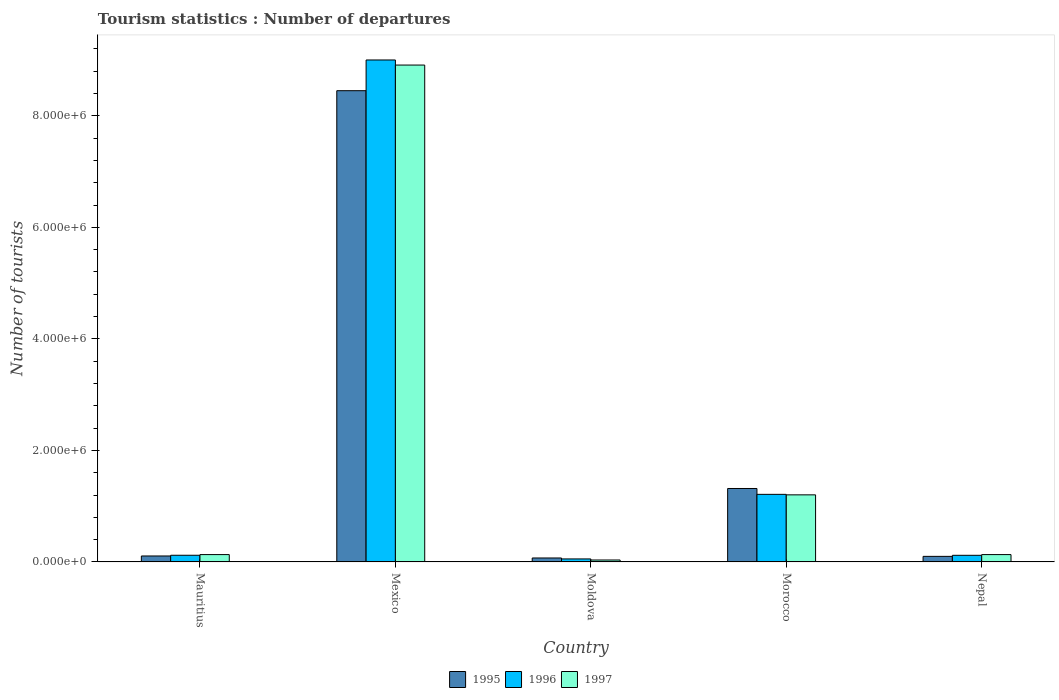How many different coloured bars are there?
Provide a succinct answer. 3. Are the number of bars per tick equal to the number of legend labels?
Offer a terse response. Yes. Are the number of bars on each tick of the X-axis equal?
Your answer should be very brief. Yes. How many bars are there on the 5th tick from the left?
Provide a short and direct response. 3. What is the label of the 1st group of bars from the left?
Your answer should be very brief. Mauritius. In how many cases, is the number of bars for a given country not equal to the number of legend labels?
Provide a short and direct response. 0. What is the number of tourist departures in 1995 in Morocco?
Your response must be concise. 1.32e+06. Across all countries, what is the maximum number of tourist departures in 1997?
Make the answer very short. 8.91e+06. Across all countries, what is the minimum number of tourist departures in 1995?
Your response must be concise. 7.10e+04. In which country was the number of tourist departures in 1995 maximum?
Offer a very short reply. Mexico. In which country was the number of tourist departures in 1996 minimum?
Provide a succinct answer. Moldova. What is the total number of tourist departures in 1997 in the graph?
Offer a terse response. 1.04e+07. What is the difference between the number of tourist departures in 1997 in Mexico and that in Nepal?
Provide a succinct answer. 8.78e+06. What is the difference between the number of tourist departures in 1997 in Moldova and the number of tourist departures in 1996 in Mauritius?
Your answer should be compact. -8.50e+04. What is the average number of tourist departures in 1996 per country?
Provide a succinct answer. 2.10e+06. What is the difference between the number of tourist departures of/in 1997 and number of tourist departures of/in 1996 in Morocco?
Offer a terse response. -9000. In how many countries, is the number of tourist departures in 1996 greater than 8400000?
Your answer should be compact. 1. What is the ratio of the number of tourist departures in 1997 in Mauritius to that in Morocco?
Provide a short and direct response. 0.11. Is the difference between the number of tourist departures in 1997 in Mexico and Nepal greater than the difference between the number of tourist departures in 1996 in Mexico and Nepal?
Ensure brevity in your answer.  No. What is the difference between the highest and the second highest number of tourist departures in 1995?
Make the answer very short. 8.34e+06. What is the difference between the highest and the lowest number of tourist departures in 1997?
Keep it short and to the point. 8.88e+06. Is the sum of the number of tourist departures in 1996 in Mexico and Nepal greater than the maximum number of tourist departures in 1997 across all countries?
Ensure brevity in your answer.  Yes. What does the 2nd bar from the left in Moldova represents?
Offer a very short reply. 1996. How many bars are there?
Offer a terse response. 15. How many countries are there in the graph?
Your response must be concise. 5. What is the difference between two consecutive major ticks on the Y-axis?
Your answer should be very brief. 2.00e+06. Are the values on the major ticks of Y-axis written in scientific E-notation?
Your answer should be compact. Yes. Does the graph contain any zero values?
Ensure brevity in your answer.  No. Where does the legend appear in the graph?
Provide a succinct answer. Bottom center. How many legend labels are there?
Your answer should be very brief. 3. What is the title of the graph?
Provide a short and direct response. Tourism statistics : Number of departures. Does "1971" appear as one of the legend labels in the graph?
Your answer should be compact. No. What is the label or title of the Y-axis?
Make the answer very short. Number of tourists. What is the Number of tourists of 1995 in Mauritius?
Keep it short and to the point. 1.07e+05. What is the Number of tourists of 1996 in Mauritius?
Provide a short and direct response. 1.20e+05. What is the Number of tourists of 1997 in Mauritius?
Give a very brief answer. 1.32e+05. What is the Number of tourists of 1995 in Mexico?
Your answer should be compact. 8.45e+06. What is the Number of tourists of 1996 in Mexico?
Your response must be concise. 9.00e+06. What is the Number of tourists of 1997 in Mexico?
Give a very brief answer. 8.91e+06. What is the Number of tourists in 1995 in Moldova?
Offer a very short reply. 7.10e+04. What is the Number of tourists of 1996 in Moldova?
Your response must be concise. 5.40e+04. What is the Number of tourists of 1997 in Moldova?
Give a very brief answer. 3.50e+04. What is the Number of tourists of 1995 in Morocco?
Your response must be concise. 1.32e+06. What is the Number of tourists in 1996 in Morocco?
Your answer should be very brief. 1.21e+06. What is the Number of tourists of 1997 in Morocco?
Make the answer very short. 1.20e+06. What is the Number of tourists in 1996 in Nepal?
Give a very brief answer. 1.19e+05. What is the Number of tourists in 1997 in Nepal?
Ensure brevity in your answer.  1.32e+05. Across all countries, what is the maximum Number of tourists in 1995?
Your answer should be very brief. 8.45e+06. Across all countries, what is the maximum Number of tourists in 1996?
Your response must be concise. 9.00e+06. Across all countries, what is the maximum Number of tourists of 1997?
Keep it short and to the point. 8.91e+06. Across all countries, what is the minimum Number of tourists in 1995?
Offer a very short reply. 7.10e+04. Across all countries, what is the minimum Number of tourists in 1996?
Your response must be concise. 5.40e+04. Across all countries, what is the minimum Number of tourists of 1997?
Ensure brevity in your answer.  3.50e+04. What is the total Number of tourists in 1995 in the graph?
Your answer should be very brief. 1.00e+07. What is the total Number of tourists in 1996 in the graph?
Ensure brevity in your answer.  1.05e+07. What is the total Number of tourists in 1997 in the graph?
Ensure brevity in your answer.  1.04e+07. What is the difference between the Number of tourists of 1995 in Mauritius and that in Mexico?
Make the answer very short. -8.34e+06. What is the difference between the Number of tourists of 1996 in Mauritius and that in Mexico?
Provide a succinct answer. -8.88e+06. What is the difference between the Number of tourists of 1997 in Mauritius and that in Mexico?
Your response must be concise. -8.78e+06. What is the difference between the Number of tourists in 1995 in Mauritius and that in Moldova?
Provide a short and direct response. 3.60e+04. What is the difference between the Number of tourists of 1996 in Mauritius and that in Moldova?
Provide a succinct answer. 6.60e+04. What is the difference between the Number of tourists of 1997 in Mauritius and that in Moldova?
Your answer should be very brief. 9.70e+04. What is the difference between the Number of tourists in 1995 in Mauritius and that in Morocco?
Your answer should be very brief. -1.21e+06. What is the difference between the Number of tourists in 1996 in Mauritius and that in Morocco?
Your answer should be very brief. -1.09e+06. What is the difference between the Number of tourists in 1997 in Mauritius and that in Morocco?
Provide a succinct answer. -1.07e+06. What is the difference between the Number of tourists of 1995 in Mauritius and that in Nepal?
Your response must be concise. 7000. What is the difference between the Number of tourists of 1996 in Mauritius and that in Nepal?
Give a very brief answer. 1000. What is the difference between the Number of tourists of 1995 in Mexico and that in Moldova?
Make the answer very short. 8.38e+06. What is the difference between the Number of tourists in 1996 in Mexico and that in Moldova?
Provide a succinct answer. 8.95e+06. What is the difference between the Number of tourists in 1997 in Mexico and that in Moldova?
Make the answer very short. 8.88e+06. What is the difference between the Number of tourists in 1995 in Mexico and that in Morocco?
Your answer should be very brief. 7.13e+06. What is the difference between the Number of tourists in 1996 in Mexico and that in Morocco?
Give a very brief answer. 7.79e+06. What is the difference between the Number of tourists of 1997 in Mexico and that in Morocco?
Your answer should be compact. 7.71e+06. What is the difference between the Number of tourists of 1995 in Mexico and that in Nepal?
Make the answer very short. 8.35e+06. What is the difference between the Number of tourists in 1996 in Mexico and that in Nepal?
Provide a short and direct response. 8.88e+06. What is the difference between the Number of tourists in 1997 in Mexico and that in Nepal?
Your response must be concise. 8.78e+06. What is the difference between the Number of tourists in 1995 in Moldova and that in Morocco?
Provide a succinct answer. -1.25e+06. What is the difference between the Number of tourists of 1996 in Moldova and that in Morocco?
Provide a short and direct response. -1.16e+06. What is the difference between the Number of tourists in 1997 in Moldova and that in Morocco?
Ensure brevity in your answer.  -1.17e+06. What is the difference between the Number of tourists of 1995 in Moldova and that in Nepal?
Your answer should be very brief. -2.90e+04. What is the difference between the Number of tourists in 1996 in Moldova and that in Nepal?
Your response must be concise. -6.50e+04. What is the difference between the Number of tourists of 1997 in Moldova and that in Nepal?
Your response must be concise. -9.70e+04. What is the difference between the Number of tourists of 1995 in Morocco and that in Nepal?
Ensure brevity in your answer.  1.22e+06. What is the difference between the Number of tourists of 1996 in Morocco and that in Nepal?
Your answer should be compact. 1.09e+06. What is the difference between the Number of tourists in 1997 in Morocco and that in Nepal?
Make the answer very short. 1.07e+06. What is the difference between the Number of tourists in 1995 in Mauritius and the Number of tourists in 1996 in Mexico?
Ensure brevity in your answer.  -8.89e+06. What is the difference between the Number of tourists of 1995 in Mauritius and the Number of tourists of 1997 in Mexico?
Your response must be concise. -8.80e+06. What is the difference between the Number of tourists in 1996 in Mauritius and the Number of tourists in 1997 in Mexico?
Ensure brevity in your answer.  -8.79e+06. What is the difference between the Number of tourists of 1995 in Mauritius and the Number of tourists of 1996 in Moldova?
Offer a terse response. 5.30e+04. What is the difference between the Number of tourists of 1995 in Mauritius and the Number of tourists of 1997 in Moldova?
Your response must be concise. 7.20e+04. What is the difference between the Number of tourists of 1996 in Mauritius and the Number of tourists of 1997 in Moldova?
Give a very brief answer. 8.50e+04. What is the difference between the Number of tourists in 1995 in Mauritius and the Number of tourists in 1996 in Morocco?
Offer a very short reply. -1.10e+06. What is the difference between the Number of tourists in 1995 in Mauritius and the Number of tourists in 1997 in Morocco?
Offer a very short reply. -1.10e+06. What is the difference between the Number of tourists in 1996 in Mauritius and the Number of tourists in 1997 in Morocco?
Keep it short and to the point. -1.08e+06. What is the difference between the Number of tourists of 1995 in Mauritius and the Number of tourists of 1996 in Nepal?
Provide a succinct answer. -1.20e+04. What is the difference between the Number of tourists of 1995 in Mauritius and the Number of tourists of 1997 in Nepal?
Offer a very short reply. -2.50e+04. What is the difference between the Number of tourists in 1996 in Mauritius and the Number of tourists in 1997 in Nepal?
Give a very brief answer. -1.20e+04. What is the difference between the Number of tourists of 1995 in Mexico and the Number of tourists of 1996 in Moldova?
Your answer should be compact. 8.40e+06. What is the difference between the Number of tourists of 1995 in Mexico and the Number of tourists of 1997 in Moldova?
Give a very brief answer. 8.42e+06. What is the difference between the Number of tourists in 1996 in Mexico and the Number of tourists in 1997 in Moldova?
Give a very brief answer. 8.97e+06. What is the difference between the Number of tourists of 1995 in Mexico and the Number of tourists of 1996 in Morocco?
Offer a terse response. 7.24e+06. What is the difference between the Number of tourists of 1995 in Mexico and the Number of tourists of 1997 in Morocco?
Give a very brief answer. 7.25e+06. What is the difference between the Number of tourists in 1996 in Mexico and the Number of tourists in 1997 in Morocco?
Your answer should be compact. 7.80e+06. What is the difference between the Number of tourists in 1995 in Mexico and the Number of tourists in 1996 in Nepal?
Offer a very short reply. 8.33e+06. What is the difference between the Number of tourists in 1995 in Mexico and the Number of tourists in 1997 in Nepal?
Your response must be concise. 8.32e+06. What is the difference between the Number of tourists in 1996 in Mexico and the Number of tourists in 1997 in Nepal?
Offer a terse response. 8.87e+06. What is the difference between the Number of tourists of 1995 in Moldova and the Number of tourists of 1996 in Morocco?
Offer a terse response. -1.14e+06. What is the difference between the Number of tourists of 1995 in Moldova and the Number of tourists of 1997 in Morocco?
Your answer should be very brief. -1.13e+06. What is the difference between the Number of tourists in 1996 in Moldova and the Number of tourists in 1997 in Morocco?
Keep it short and to the point. -1.15e+06. What is the difference between the Number of tourists of 1995 in Moldova and the Number of tourists of 1996 in Nepal?
Your response must be concise. -4.80e+04. What is the difference between the Number of tourists in 1995 in Moldova and the Number of tourists in 1997 in Nepal?
Give a very brief answer. -6.10e+04. What is the difference between the Number of tourists of 1996 in Moldova and the Number of tourists of 1997 in Nepal?
Keep it short and to the point. -7.80e+04. What is the difference between the Number of tourists in 1995 in Morocco and the Number of tourists in 1996 in Nepal?
Make the answer very short. 1.20e+06. What is the difference between the Number of tourists in 1995 in Morocco and the Number of tourists in 1997 in Nepal?
Give a very brief answer. 1.18e+06. What is the difference between the Number of tourists of 1996 in Morocco and the Number of tourists of 1997 in Nepal?
Offer a very short reply. 1.08e+06. What is the average Number of tourists of 1995 per country?
Provide a succinct answer. 2.01e+06. What is the average Number of tourists of 1996 per country?
Make the answer very short. 2.10e+06. What is the average Number of tourists of 1997 per country?
Provide a short and direct response. 2.08e+06. What is the difference between the Number of tourists of 1995 and Number of tourists of 1996 in Mauritius?
Provide a succinct answer. -1.30e+04. What is the difference between the Number of tourists in 1995 and Number of tourists in 1997 in Mauritius?
Ensure brevity in your answer.  -2.50e+04. What is the difference between the Number of tourists of 1996 and Number of tourists of 1997 in Mauritius?
Keep it short and to the point. -1.20e+04. What is the difference between the Number of tourists of 1995 and Number of tourists of 1996 in Mexico?
Offer a very short reply. -5.51e+05. What is the difference between the Number of tourists of 1995 and Number of tourists of 1997 in Mexico?
Provide a short and direct response. -4.60e+05. What is the difference between the Number of tourists in 1996 and Number of tourists in 1997 in Mexico?
Ensure brevity in your answer.  9.10e+04. What is the difference between the Number of tourists in 1995 and Number of tourists in 1996 in Moldova?
Your response must be concise. 1.70e+04. What is the difference between the Number of tourists of 1995 and Number of tourists of 1997 in Moldova?
Offer a very short reply. 3.60e+04. What is the difference between the Number of tourists in 1996 and Number of tourists in 1997 in Moldova?
Offer a terse response. 1.90e+04. What is the difference between the Number of tourists in 1995 and Number of tourists in 1996 in Morocco?
Provide a short and direct response. 1.05e+05. What is the difference between the Number of tourists of 1995 and Number of tourists of 1997 in Morocco?
Give a very brief answer. 1.14e+05. What is the difference between the Number of tourists of 1996 and Number of tourists of 1997 in Morocco?
Offer a terse response. 9000. What is the difference between the Number of tourists in 1995 and Number of tourists in 1996 in Nepal?
Your response must be concise. -1.90e+04. What is the difference between the Number of tourists of 1995 and Number of tourists of 1997 in Nepal?
Your answer should be very brief. -3.20e+04. What is the difference between the Number of tourists in 1996 and Number of tourists in 1997 in Nepal?
Your answer should be very brief. -1.30e+04. What is the ratio of the Number of tourists of 1995 in Mauritius to that in Mexico?
Provide a succinct answer. 0.01. What is the ratio of the Number of tourists in 1996 in Mauritius to that in Mexico?
Offer a terse response. 0.01. What is the ratio of the Number of tourists in 1997 in Mauritius to that in Mexico?
Offer a terse response. 0.01. What is the ratio of the Number of tourists in 1995 in Mauritius to that in Moldova?
Make the answer very short. 1.51. What is the ratio of the Number of tourists in 1996 in Mauritius to that in Moldova?
Your response must be concise. 2.22. What is the ratio of the Number of tourists of 1997 in Mauritius to that in Moldova?
Your answer should be very brief. 3.77. What is the ratio of the Number of tourists of 1995 in Mauritius to that in Morocco?
Provide a short and direct response. 0.08. What is the ratio of the Number of tourists of 1996 in Mauritius to that in Morocco?
Your response must be concise. 0.1. What is the ratio of the Number of tourists of 1997 in Mauritius to that in Morocco?
Your answer should be compact. 0.11. What is the ratio of the Number of tourists of 1995 in Mauritius to that in Nepal?
Your answer should be compact. 1.07. What is the ratio of the Number of tourists of 1996 in Mauritius to that in Nepal?
Keep it short and to the point. 1.01. What is the ratio of the Number of tourists in 1997 in Mauritius to that in Nepal?
Your answer should be very brief. 1. What is the ratio of the Number of tourists in 1995 in Mexico to that in Moldova?
Offer a terse response. 119.01. What is the ratio of the Number of tourists in 1996 in Mexico to that in Moldova?
Offer a terse response. 166.69. What is the ratio of the Number of tourists in 1997 in Mexico to that in Moldova?
Your response must be concise. 254.57. What is the ratio of the Number of tourists in 1995 in Mexico to that in Morocco?
Offer a very short reply. 6.42. What is the ratio of the Number of tourists in 1996 in Mexico to that in Morocco?
Keep it short and to the point. 7.43. What is the ratio of the Number of tourists of 1997 in Mexico to that in Morocco?
Ensure brevity in your answer.  7.41. What is the ratio of the Number of tourists in 1995 in Mexico to that in Nepal?
Ensure brevity in your answer.  84.5. What is the ratio of the Number of tourists of 1996 in Mexico to that in Nepal?
Your answer should be very brief. 75.64. What is the ratio of the Number of tourists in 1997 in Mexico to that in Nepal?
Offer a terse response. 67.5. What is the ratio of the Number of tourists of 1995 in Moldova to that in Morocco?
Ensure brevity in your answer.  0.05. What is the ratio of the Number of tourists in 1996 in Moldova to that in Morocco?
Keep it short and to the point. 0.04. What is the ratio of the Number of tourists of 1997 in Moldova to that in Morocco?
Offer a very short reply. 0.03. What is the ratio of the Number of tourists in 1995 in Moldova to that in Nepal?
Make the answer very short. 0.71. What is the ratio of the Number of tourists in 1996 in Moldova to that in Nepal?
Make the answer very short. 0.45. What is the ratio of the Number of tourists in 1997 in Moldova to that in Nepal?
Keep it short and to the point. 0.27. What is the ratio of the Number of tourists of 1995 in Morocco to that in Nepal?
Provide a short and direct response. 13.17. What is the ratio of the Number of tourists of 1996 in Morocco to that in Nepal?
Give a very brief answer. 10.18. What is the ratio of the Number of tourists in 1997 in Morocco to that in Nepal?
Offer a very short reply. 9.11. What is the difference between the highest and the second highest Number of tourists in 1995?
Ensure brevity in your answer.  7.13e+06. What is the difference between the highest and the second highest Number of tourists of 1996?
Ensure brevity in your answer.  7.79e+06. What is the difference between the highest and the second highest Number of tourists of 1997?
Your answer should be very brief. 7.71e+06. What is the difference between the highest and the lowest Number of tourists of 1995?
Your answer should be very brief. 8.38e+06. What is the difference between the highest and the lowest Number of tourists of 1996?
Provide a succinct answer. 8.95e+06. What is the difference between the highest and the lowest Number of tourists in 1997?
Offer a very short reply. 8.88e+06. 